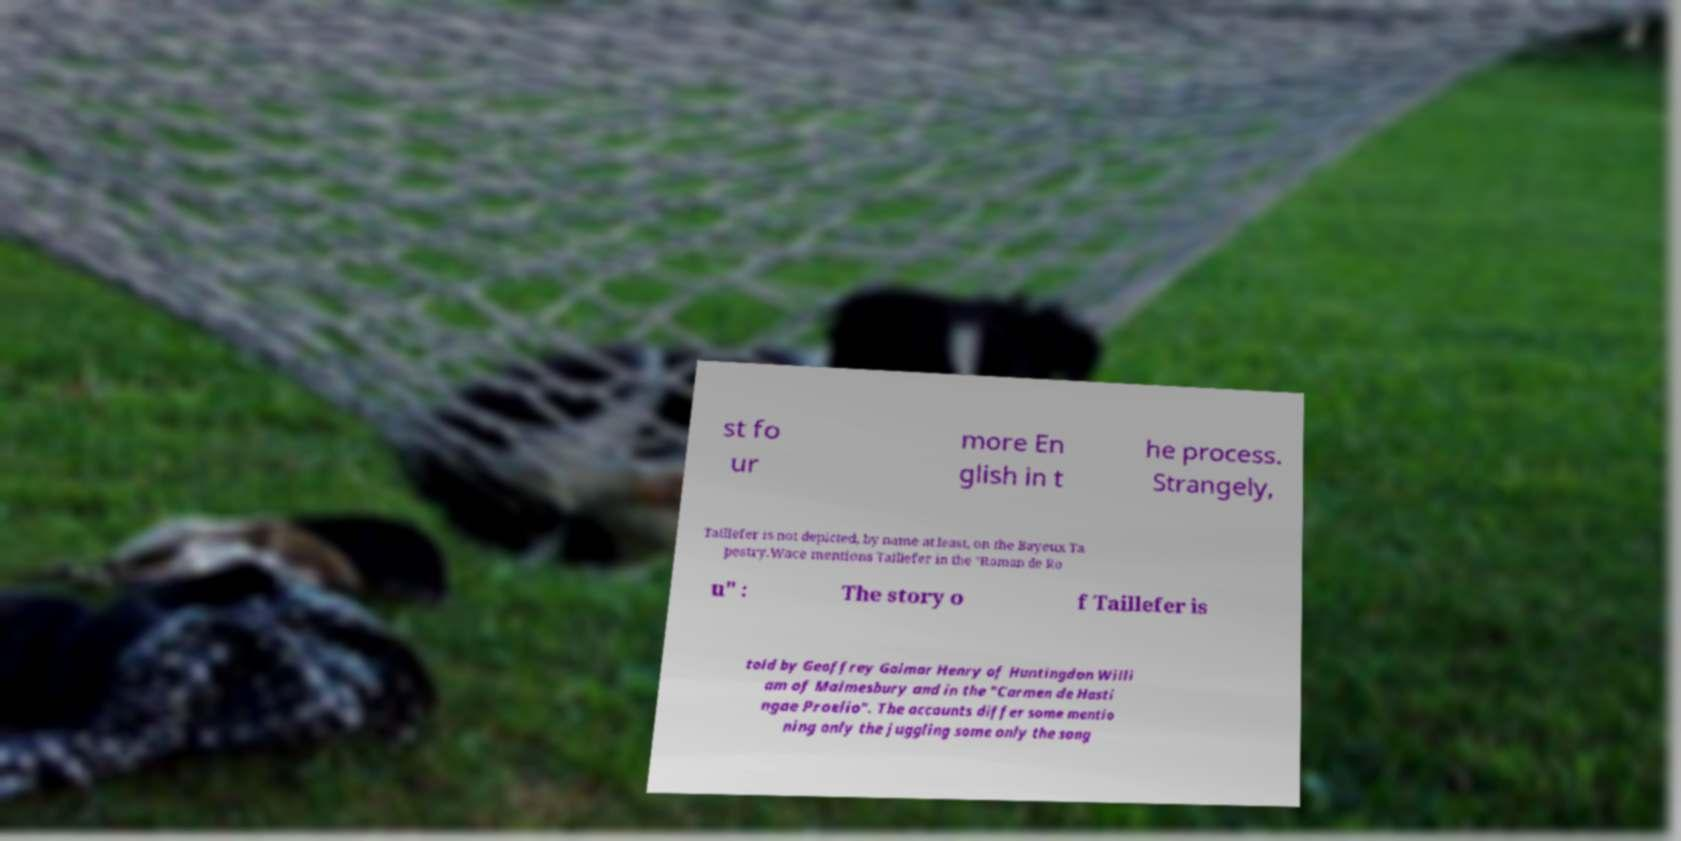Could you extract and type out the text from this image? st fo ur more En glish in t he process. Strangely, Taillefer is not depicted, by name at least, on the Bayeux Ta pestry.Wace mentions Taillefer in the "Roman de Ro u" : The story o f Taillefer is told by Geoffrey Gaimar Henry of Huntingdon Willi am of Malmesbury and in the "Carmen de Hasti ngae Proelio". The accounts differ some mentio ning only the juggling some only the song 